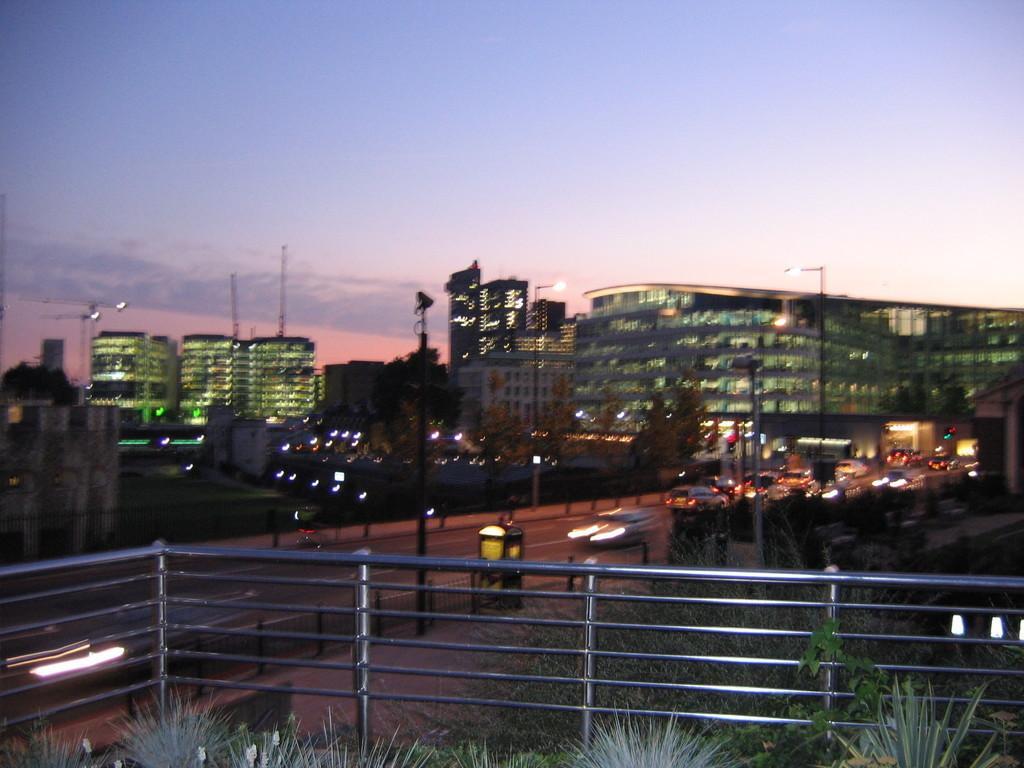Could you give a brief overview of what you see in this image? In the image there is fence in the front with some plants on side of it, in the background there are many vehicles moving on road and over the whole background there are buildings all over the image, this is clicked at dawn time and above its sky. 